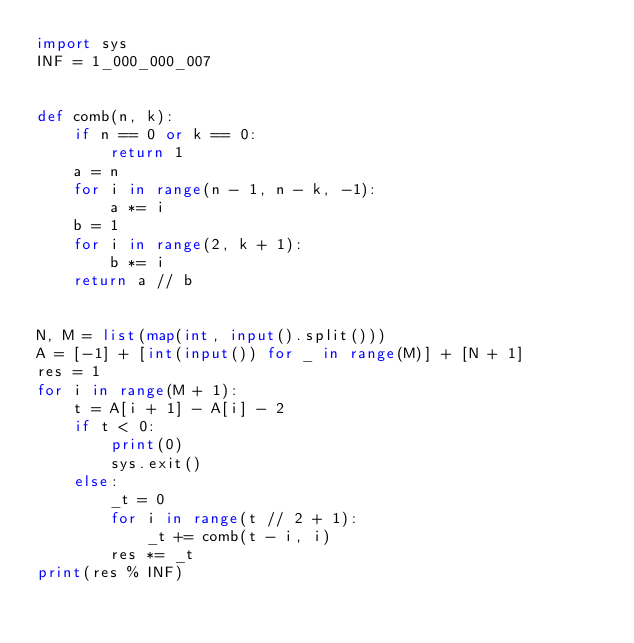Convert code to text. <code><loc_0><loc_0><loc_500><loc_500><_Python_>import sys
INF = 1_000_000_007


def comb(n, k):
    if n == 0 or k == 0:
        return 1
    a = n
    for i in range(n - 1, n - k, -1):
        a *= i
    b = 1
    for i in range(2, k + 1):
        b *= i
    return a // b


N, M = list(map(int, input().split()))
A = [-1] + [int(input()) for _ in range(M)] + [N + 1]
res = 1
for i in range(M + 1):
    t = A[i + 1] - A[i] - 2
    if t < 0:
        print(0)
        sys.exit()
    else:
        _t = 0
        for i in range(t // 2 + 1):
            _t += comb(t - i, i)
        res *= _t
print(res % INF)
</code> 